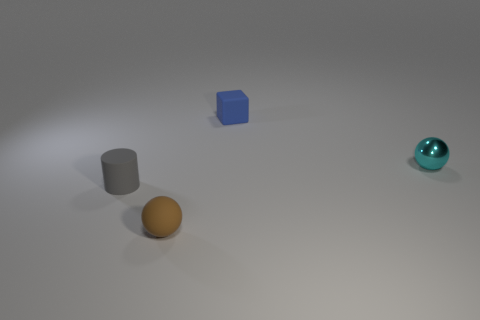Are there any large things that have the same material as the tiny brown sphere?
Provide a short and direct response. No. What color is the tiny matte thing that is both to the right of the gray cylinder and in front of the tiny cyan metallic thing?
Your answer should be very brief. Brown. What number of other things are the same color as the metal ball?
Your response must be concise. 0. What material is the ball that is on the right side of the tiny rubber object that is on the right side of the ball on the left side of the cyan object?
Provide a short and direct response. Metal. What number of cubes are cyan matte objects or small blue rubber objects?
Your answer should be very brief. 1. There is a small matte object that is left of the sphere left of the cyan sphere; how many blue blocks are on the right side of it?
Provide a succinct answer. 1. Is the small metal object the same shape as the brown object?
Keep it short and to the point. Yes. Do the sphere that is on the left side of the small matte block and the small object that is on the left side of the brown matte object have the same material?
Provide a short and direct response. Yes. What number of things are either balls left of the blue matte object or tiny spheres that are left of the tiny blue matte thing?
Your answer should be very brief. 1. Are there any other things that are the same shape as the tiny gray object?
Provide a short and direct response. No. 